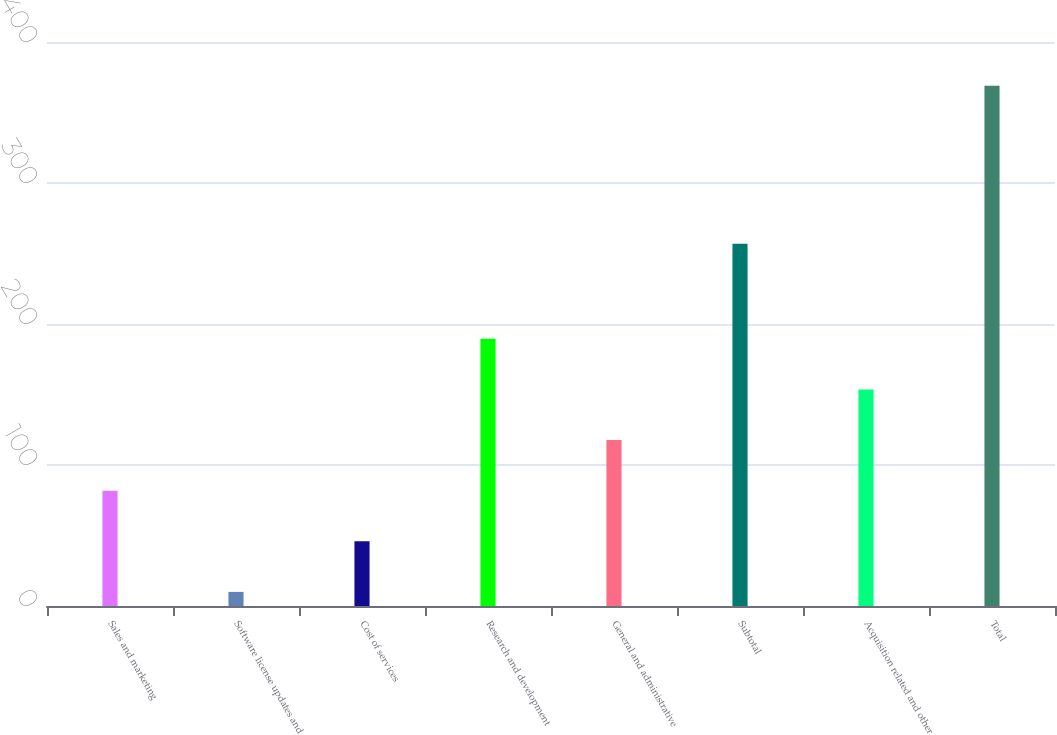Convert chart. <chart><loc_0><loc_0><loc_500><loc_500><bar_chart><fcel>Sales and marketing<fcel>Software license updates and<fcel>Cost of services<fcel>Research and development<fcel>General and administrative<fcel>Subtotal<fcel>Acquisition related and other<fcel>Total<nl><fcel>81.8<fcel>10<fcel>45.9<fcel>189.5<fcel>117.7<fcel>257<fcel>153.6<fcel>369<nl></chart> 